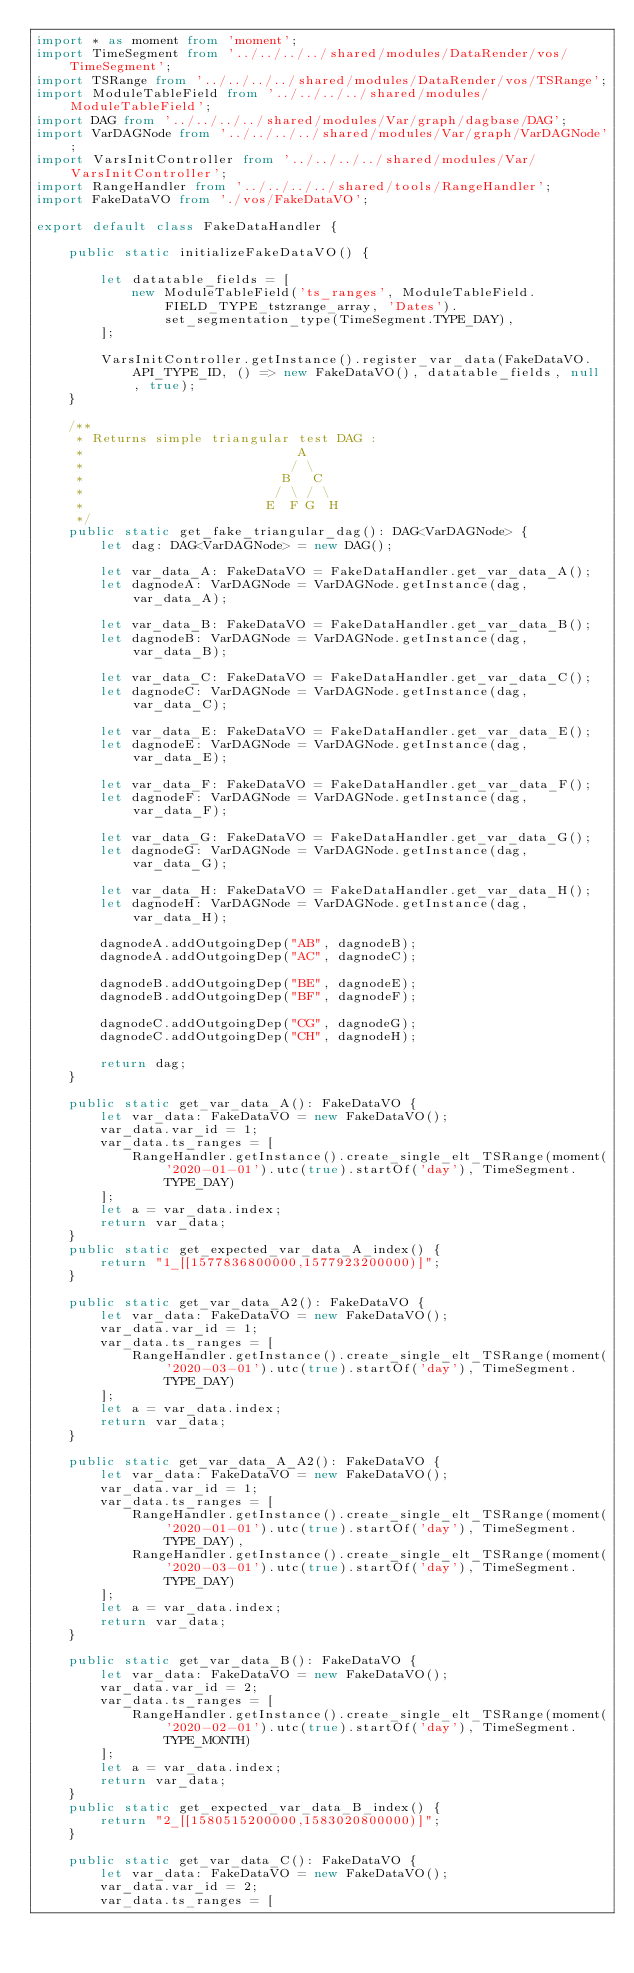Convert code to text. <code><loc_0><loc_0><loc_500><loc_500><_TypeScript_>import * as moment from 'moment';
import TimeSegment from '../../../../shared/modules/DataRender/vos/TimeSegment';
import TSRange from '../../../../shared/modules/DataRender/vos/TSRange';
import ModuleTableField from '../../../../shared/modules/ModuleTableField';
import DAG from '../../../../shared/modules/Var/graph/dagbase/DAG';
import VarDAGNode from '../../../../shared/modules/Var/graph/VarDAGNode';
import VarsInitController from '../../../../shared/modules/Var/VarsInitController';
import RangeHandler from '../../../../shared/tools/RangeHandler';
import FakeDataVO from './vos/FakeDataVO';

export default class FakeDataHandler {

    public static initializeFakeDataVO() {

        let datatable_fields = [
            new ModuleTableField('ts_ranges', ModuleTableField.FIELD_TYPE_tstzrange_array, 'Dates').set_segmentation_type(TimeSegment.TYPE_DAY),
        ];

        VarsInitController.getInstance().register_var_data(FakeDataVO.API_TYPE_ID, () => new FakeDataVO(), datatable_fields, null, true);
    }

    /**
     * Returns simple triangular test DAG :
     *                           A
     *                          / \
     *                         B   C
     *                        / \ / \
     *                       E  F G  H
     */
    public static get_fake_triangular_dag(): DAG<VarDAGNode> {
        let dag: DAG<VarDAGNode> = new DAG();

        let var_data_A: FakeDataVO = FakeDataHandler.get_var_data_A();
        let dagnodeA: VarDAGNode = VarDAGNode.getInstance(dag, var_data_A);

        let var_data_B: FakeDataVO = FakeDataHandler.get_var_data_B();
        let dagnodeB: VarDAGNode = VarDAGNode.getInstance(dag, var_data_B);

        let var_data_C: FakeDataVO = FakeDataHandler.get_var_data_C();
        let dagnodeC: VarDAGNode = VarDAGNode.getInstance(dag, var_data_C);

        let var_data_E: FakeDataVO = FakeDataHandler.get_var_data_E();
        let dagnodeE: VarDAGNode = VarDAGNode.getInstance(dag, var_data_E);

        let var_data_F: FakeDataVO = FakeDataHandler.get_var_data_F();
        let dagnodeF: VarDAGNode = VarDAGNode.getInstance(dag, var_data_F);

        let var_data_G: FakeDataVO = FakeDataHandler.get_var_data_G();
        let dagnodeG: VarDAGNode = VarDAGNode.getInstance(dag, var_data_G);

        let var_data_H: FakeDataVO = FakeDataHandler.get_var_data_H();
        let dagnodeH: VarDAGNode = VarDAGNode.getInstance(dag, var_data_H);

        dagnodeA.addOutgoingDep("AB", dagnodeB);
        dagnodeA.addOutgoingDep("AC", dagnodeC);

        dagnodeB.addOutgoingDep("BE", dagnodeE);
        dagnodeB.addOutgoingDep("BF", dagnodeF);

        dagnodeC.addOutgoingDep("CG", dagnodeG);
        dagnodeC.addOutgoingDep("CH", dagnodeH);

        return dag;
    }

    public static get_var_data_A(): FakeDataVO {
        let var_data: FakeDataVO = new FakeDataVO();
        var_data.var_id = 1;
        var_data.ts_ranges = [
            RangeHandler.getInstance().create_single_elt_TSRange(moment('2020-01-01').utc(true).startOf('day'), TimeSegment.TYPE_DAY)
        ];
        let a = var_data.index;
        return var_data;
    }
    public static get_expected_var_data_A_index() {
        return "1_[[1577836800000,1577923200000)]";
    }

    public static get_var_data_A2(): FakeDataVO {
        let var_data: FakeDataVO = new FakeDataVO();
        var_data.var_id = 1;
        var_data.ts_ranges = [
            RangeHandler.getInstance().create_single_elt_TSRange(moment('2020-03-01').utc(true).startOf('day'), TimeSegment.TYPE_DAY)
        ];
        let a = var_data.index;
        return var_data;
    }

    public static get_var_data_A_A2(): FakeDataVO {
        let var_data: FakeDataVO = new FakeDataVO();
        var_data.var_id = 1;
        var_data.ts_ranges = [
            RangeHandler.getInstance().create_single_elt_TSRange(moment('2020-01-01').utc(true).startOf('day'), TimeSegment.TYPE_DAY),
            RangeHandler.getInstance().create_single_elt_TSRange(moment('2020-03-01').utc(true).startOf('day'), TimeSegment.TYPE_DAY)
        ];
        let a = var_data.index;
        return var_data;
    }

    public static get_var_data_B(): FakeDataVO {
        let var_data: FakeDataVO = new FakeDataVO();
        var_data.var_id = 2;
        var_data.ts_ranges = [
            RangeHandler.getInstance().create_single_elt_TSRange(moment('2020-02-01').utc(true).startOf('day'), TimeSegment.TYPE_MONTH)
        ];
        let a = var_data.index;
        return var_data;
    }
    public static get_expected_var_data_B_index() {
        return "2_[[1580515200000,1583020800000)]";
    }

    public static get_var_data_C(): FakeDataVO {
        let var_data: FakeDataVO = new FakeDataVO();
        var_data.var_id = 2;
        var_data.ts_ranges = [</code> 